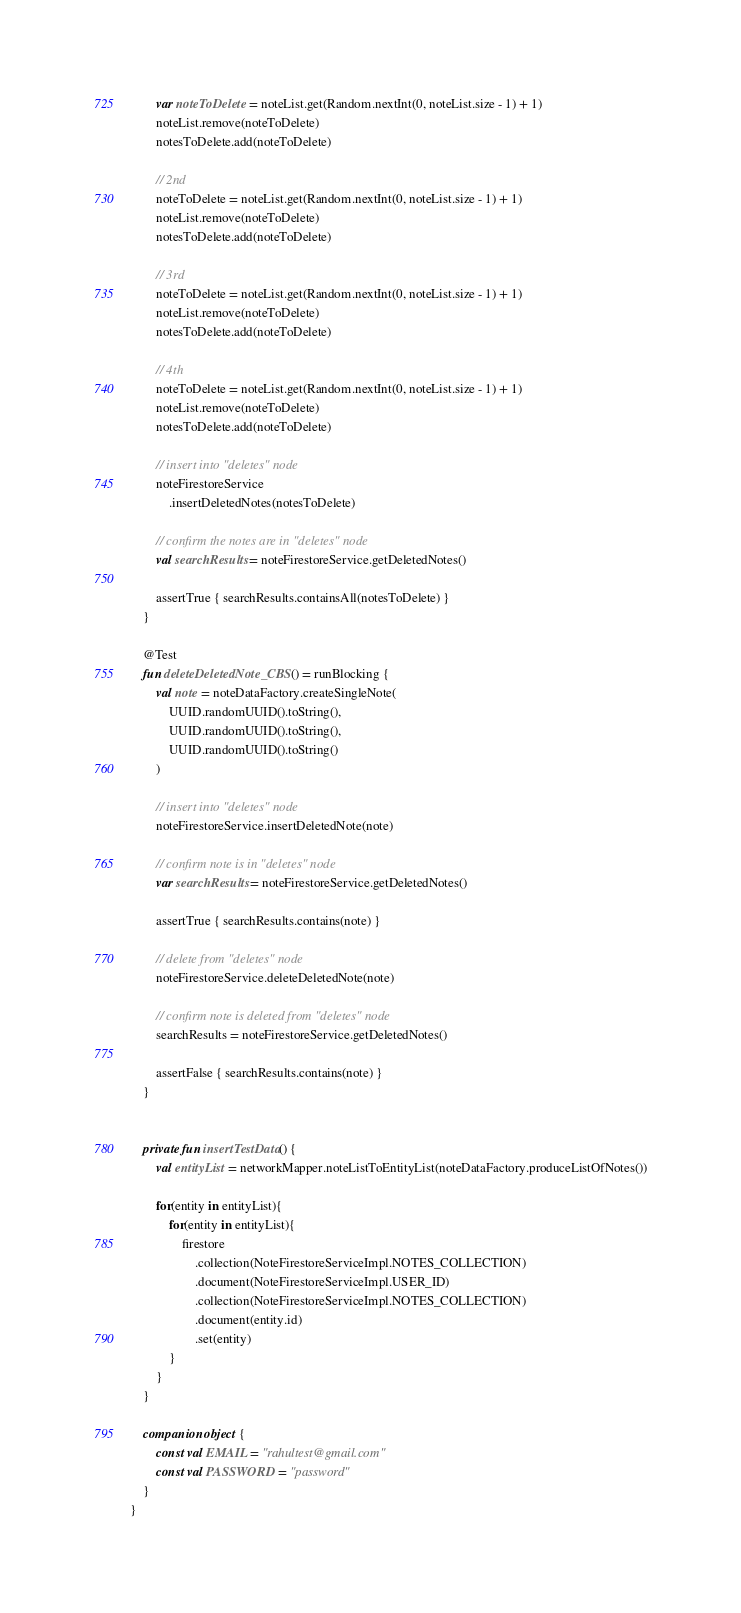Convert code to text. <code><loc_0><loc_0><loc_500><loc_500><_Kotlin_>        var noteToDelete = noteList.get(Random.nextInt(0, noteList.size - 1) + 1)
        noteList.remove(noteToDelete)
        notesToDelete.add(noteToDelete)

        // 2nd
        noteToDelete = noteList.get(Random.nextInt(0, noteList.size - 1) + 1)
        noteList.remove(noteToDelete)
        notesToDelete.add(noteToDelete)

        // 3rd
        noteToDelete = noteList.get(Random.nextInt(0, noteList.size - 1) + 1)
        noteList.remove(noteToDelete)
        notesToDelete.add(noteToDelete)

        // 4th
        noteToDelete = noteList.get(Random.nextInt(0, noteList.size - 1) + 1)
        noteList.remove(noteToDelete)
        notesToDelete.add(noteToDelete)

        // insert into "deletes" node
        noteFirestoreService
            .insertDeletedNotes(notesToDelete)

        // confirm the notes are in "deletes" node
        val searchResults = noteFirestoreService.getDeletedNotes()

        assertTrue { searchResults.containsAll(notesToDelete) }
    }

    @Test
    fun deleteDeletedNote_CBS() = runBlocking {
        val note = noteDataFactory.createSingleNote(
            UUID.randomUUID().toString(),
            UUID.randomUUID().toString(),
            UUID.randomUUID().toString()
        )

        // insert into "deletes" node
        noteFirestoreService.insertDeletedNote(note)

        // confirm note is in "deletes" node
        var searchResults = noteFirestoreService.getDeletedNotes()

        assertTrue { searchResults.contains(note) }

        // delete from "deletes" node
        noteFirestoreService.deleteDeletedNote(note)

        // confirm note is deleted from "deletes" node
        searchResults = noteFirestoreService.getDeletedNotes()

        assertFalse { searchResults.contains(note) }
    }


    private fun insertTestData() {
        val entityList = networkMapper.noteListToEntityList(noteDataFactory.produceListOfNotes())

        for(entity in entityList){
            for(entity in entityList){
                firestore
                    .collection(NoteFirestoreServiceImpl.NOTES_COLLECTION)
                    .document(NoteFirestoreServiceImpl.USER_ID)
                    .collection(NoteFirestoreServiceImpl.NOTES_COLLECTION)
                    .document(entity.id)
                    .set(entity)
            }
        }
    }

    companion object {
        const val EMAIL = "rahultest@gmail.com"
        const val PASSWORD = "password"
    }
}</code> 